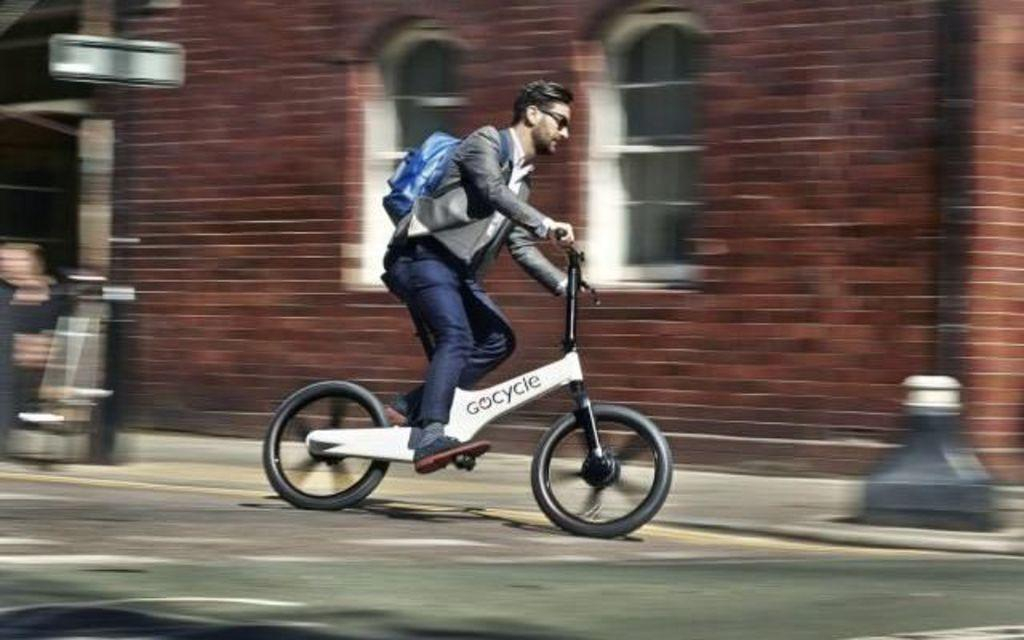What is the person in the image doing? There is a person cycling in the image. Where is the person cycling? The person is on the road. What can be seen in the background of the image? There is a building in the background of the image. How much debt does the person cycling have in the image? There is no information about the person's debt in the image. What is the person pulling behind them while cycling in the image? There is no object being pulled by the person cycling in the image. 